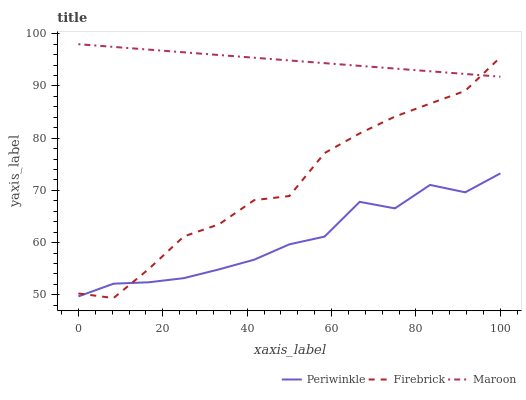Does Periwinkle have the minimum area under the curve?
Answer yes or no. Yes. Does Maroon have the maximum area under the curve?
Answer yes or no. Yes. Does Maroon have the minimum area under the curve?
Answer yes or no. No. Does Periwinkle have the maximum area under the curve?
Answer yes or no. No. Is Maroon the smoothest?
Answer yes or no. Yes. Is Periwinkle the roughest?
Answer yes or no. Yes. Is Periwinkle the smoothest?
Answer yes or no. No. Is Maroon the roughest?
Answer yes or no. No. Does Firebrick have the lowest value?
Answer yes or no. Yes. Does Periwinkle have the lowest value?
Answer yes or no. No. Does Maroon have the highest value?
Answer yes or no. Yes. Does Periwinkle have the highest value?
Answer yes or no. No. Is Periwinkle less than Maroon?
Answer yes or no. Yes. Is Maroon greater than Periwinkle?
Answer yes or no. Yes. Does Firebrick intersect Maroon?
Answer yes or no. Yes. Is Firebrick less than Maroon?
Answer yes or no. No. Is Firebrick greater than Maroon?
Answer yes or no. No. Does Periwinkle intersect Maroon?
Answer yes or no. No. 